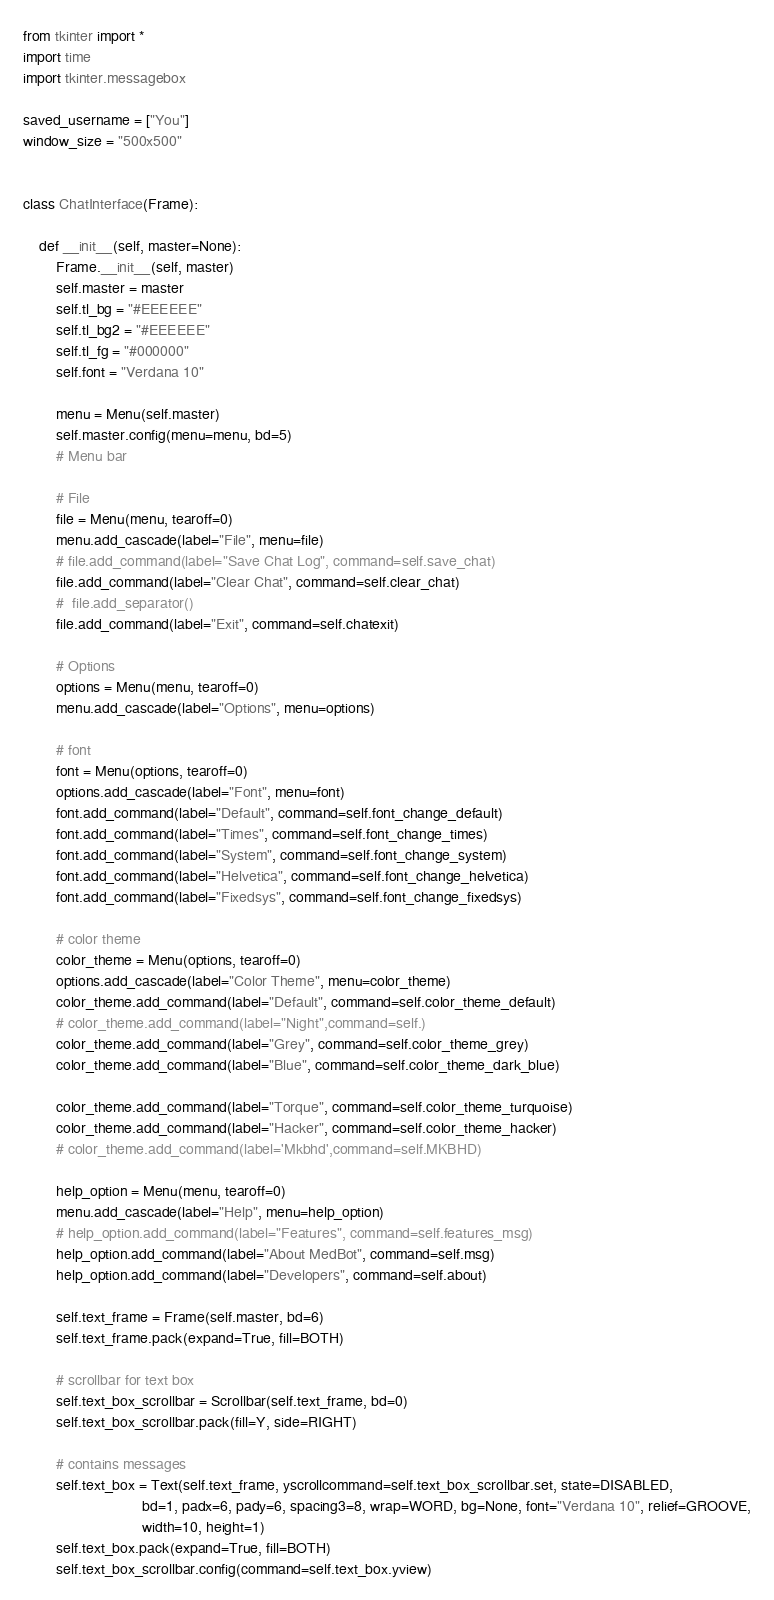Convert code to text. <code><loc_0><loc_0><loc_500><loc_500><_Python_>from tkinter import *
import time
import tkinter.messagebox

saved_username = ["You"]
window_size = "500x500"


class ChatInterface(Frame):

    def __init__(self, master=None):
        Frame.__init__(self, master)
        self.master = master
        self.tl_bg = "#EEEEEE"
        self.tl_bg2 = "#EEEEEE"
        self.tl_fg = "#000000"
        self.font = "Verdana 10"

        menu = Menu(self.master)
        self.master.config(menu=menu, bd=5)
        # Menu bar

        # File
        file = Menu(menu, tearoff=0)
        menu.add_cascade(label="File", menu=file)
        # file.add_command(label="Save Chat Log", command=self.save_chat)
        file.add_command(label="Clear Chat", command=self.clear_chat)
        #  file.add_separator()
        file.add_command(label="Exit", command=self.chatexit)

        # Options
        options = Menu(menu, tearoff=0)
        menu.add_cascade(label="Options", menu=options)

        # font
        font = Menu(options, tearoff=0)
        options.add_cascade(label="Font", menu=font)
        font.add_command(label="Default", command=self.font_change_default)
        font.add_command(label="Times", command=self.font_change_times)
        font.add_command(label="System", command=self.font_change_system)
        font.add_command(label="Helvetica", command=self.font_change_helvetica)
        font.add_command(label="Fixedsys", command=self.font_change_fixedsys)

        # color theme
        color_theme = Menu(options, tearoff=0)
        options.add_cascade(label="Color Theme", menu=color_theme)
        color_theme.add_command(label="Default", command=self.color_theme_default)
        # color_theme.add_command(label="Night",command=self.)
        color_theme.add_command(label="Grey", command=self.color_theme_grey)
        color_theme.add_command(label="Blue", command=self.color_theme_dark_blue)

        color_theme.add_command(label="Torque", command=self.color_theme_turquoise)
        color_theme.add_command(label="Hacker", command=self.color_theme_hacker)
        # color_theme.add_command(label='Mkbhd',command=self.MKBHD)

        help_option = Menu(menu, tearoff=0)
        menu.add_cascade(label="Help", menu=help_option)
        # help_option.add_command(label="Features", command=self.features_msg)
        help_option.add_command(label="About MedBot", command=self.msg)
        help_option.add_command(label="Developers", command=self.about)

        self.text_frame = Frame(self.master, bd=6)
        self.text_frame.pack(expand=True, fill=BOTH)

        # scrollbar for text box
        self.text_box_scrollbar = Scrollbar(self.text_frame, bd=0)
        self.text_box_scrollbar.pack(fill=Y, side=RIGHT)

        # contains messages
        self.text_box = Text(self.text_frame, yscrollcommand=self.text_box_scrollbar.set, state=DISABLED,
                             bd=1, padx=6, pady=6, spacing3=8, wrap=WORD, bg=None, font="Verdana 10", relief=GROOVE,
                             width=10, height=1)
        self.text_box.pack(expand=True, fill=BOTH)
        self.text_box_scrollbar.config(command=self.text_box.yview)</code> 